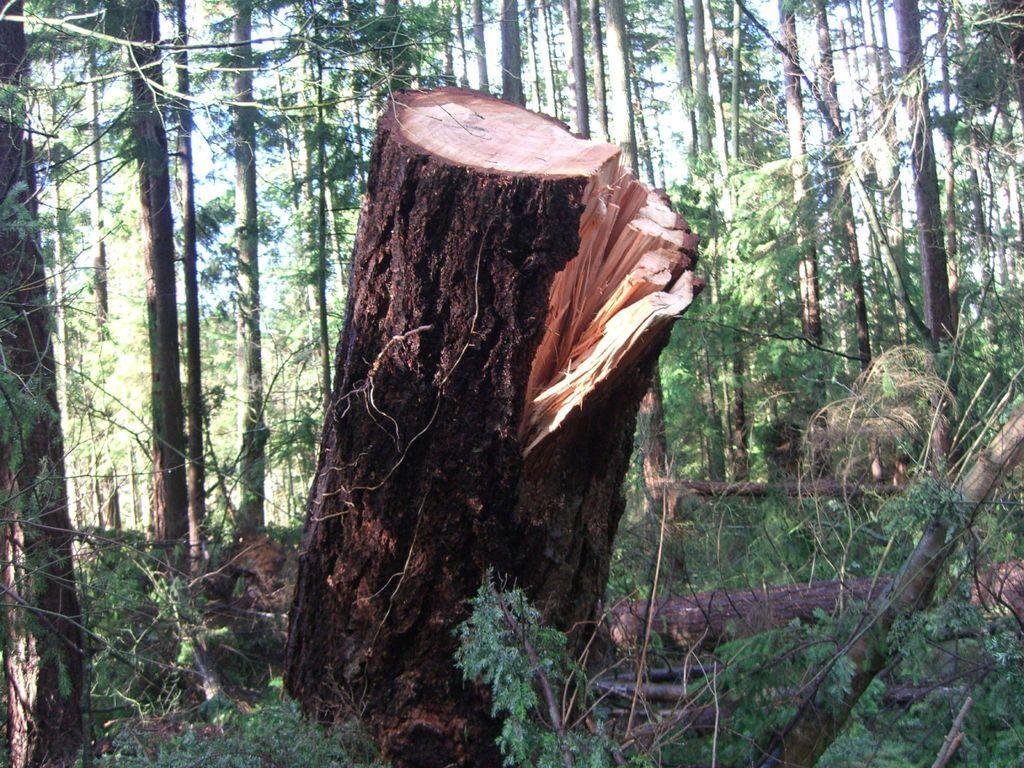Can you describe this image briefly? We can see tree trunk and plants. Background we can see trees. 